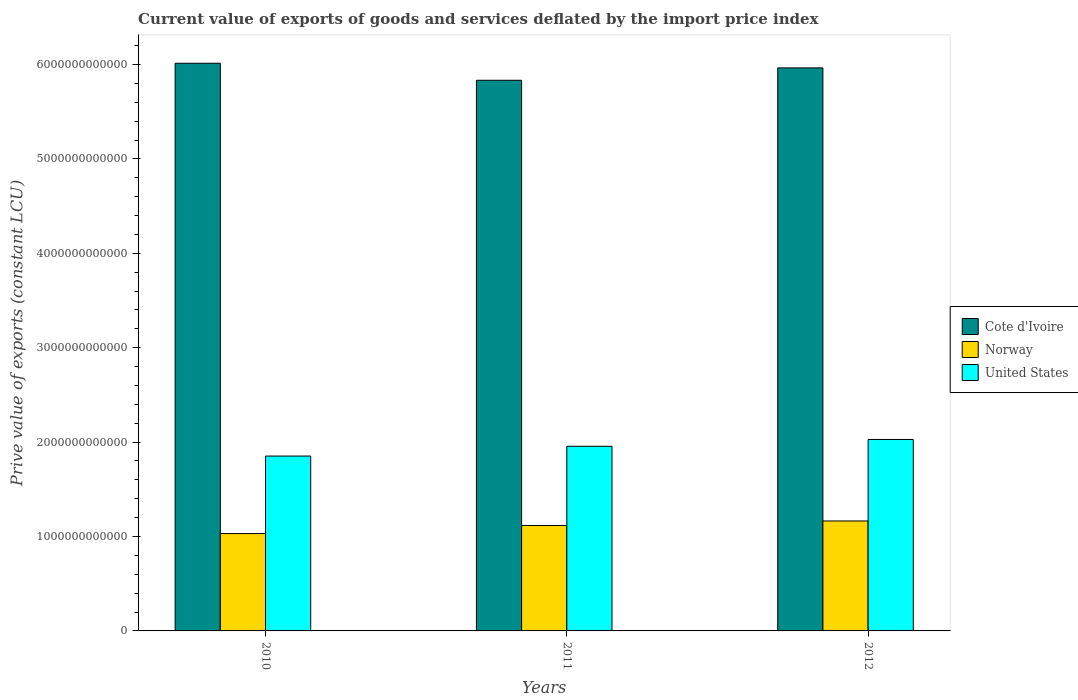Are the number of bars on each tick of the X-axis equal?
Provide a succinct answer. Yes. How many bars are there on the 2nd tick from the left?
Your response must be concise. 3. What is the label of the 1st group of bars from the left?
Your answer should be very brief. 2010. In how many cases, is the number of bars for a given year not equal to the number of legend labels?
Keep it short and to the point. 0. What is the prive value of exports in Cote d'Ivoire in 2010?
Offer a terse response. 6.01e+12. Across all years, what is the maximum prive value of exports in Norway?
Your answer should be compact. 1.16e+12. Across all years, what is the minimum prive value of exports in Norway?
Keep it short and to the point. 1.03e+12. In which year was the prive value of exports in United States maximum?
Provide a short and direct response. 2012. What is the total prive value of exports in Cote d'Ivoire in the graph?
Offer a very short reply. 1.78e+13. What is the difference between the prive value of exports in Cote d'Ivoire in 2010 and that in 2011?
Give a very brief answer. 1.80e+11. What is the difference between the prive value of exports in Norway in 2010 and the prive value of exports in United States in 2012?
Make the answer very short. -9.97e+11. What is the average prive value of exports in Cote d'Ivoire per year?
Your answer should be compact. 5.94e+12. In the year 2010, what is the difference between the prive value of exports in Norway and prive value of exports in United States?
Your answer should be compact. -8.21e+11. What is the ratio of the prive value of exports in Norway in 2011 to that in 2012?
Ensure brevity in your answer.  0.96. Is the prive value of exports in Cote d'Ivoire in 2010 less than that in 2012?
Keep it short and to the point. No. Is the difference between the prive value of exports in Norway in 2010 and 2012 greater than the difference between the prive value of exports in United States in 2010 and 2012?
Your answer should be compact. Yes. What is the difference between the highest and the second highest prive value of exports in Norway?
Ensure brevity in your answer.  4.80e+1. What is the difference between the highest and the lowest prive value of exports in United States?
Offer a terse response. 1.76e+11. In how many years, is the prive value of exports in United States greater than the average prive value of exports in United States taken over all years?
Provide a short and direct response. 2. Is the sum of the prive value of exports in Norway in 2010 and 2011 greater than the maximum prive value of exports in Cote d'Ivoire across all years?
Your answer should be very brief. No. What does the 3rd bar from the left in 2011 represents?
Provide a succinct answer. United States. What does the 3rd bar from the right in 2012 represents?
Your response must be concise. Cote d'Ivoire. How many bars are there?
Your answer should be very brief. 9. Are all the bars in the graph horizontal?
Provide a succinct answer. No. What is the difference between two consecutive major ticks on the Y-axis?
Ensure brevity in your answer.  1.00e+12. Are the values on the major ticks of Y-axis written in scientific E-notation?
Keep it short and to the point. No. Does the graph contain grids?
Keep it short and to the point. No. Where does the legend appear in the graph?
Offer a very short reply. Center right. How are the legend labels stacked?
Your answer should be compact. Vertical. What is the title of the graph?
Keep it short and to the point. Current value of exports of goods and services deflated by the import price index. Does "Maldives" appear as one of the legend labels in the graph?
Offer a very short reply. No. What is the label or title of the Y-axis?
Offer a terse response. Prive value of exports (constant LCU). What is the Prive value of exports (constant LCU) in Cote d'Ivoire in 2010?
Offer a terse response. 6.01e+12. What is the Prive value of exports (constant LCU) of Norway in 2010?
Keep it short and to the point. 1.03e+12. What is the Prive value of exports (constant LCU) in United States in 2010?
Offer a terse response. 1.85e+12. What is the Prive value of exports (constant LCU) of Cote d'Ivoire in 2011?
Provide a short and direct response. 5.83e+12. What is the Prive value of exports (constant LCU) of Norway in 2011?
Give a very brief answer. 1.12e+12. What is the Prive value of exports (constant LCU) of United States in 2011?
Give a very brief answer. 1.96e+12. What is the Prive value of exports (constant LCU) in Cote d'Ivoire in 2012?
Make the answer very short. 5.96e+12. What is the Prive value of exports (constant LCU) of Norway in 2012?
Make the answer very short. 1.16e+12. What is the Prive value of exports (constant LCU) of United States in 2012?
Keep it short and to the point. 2.03e+12. Across all years, what is the maximum Prive value of exports (constant LCU) of Cote d'Ivoire?
Make the answer very short. 6.01e+12. Across all years, what is the maximum Prive value of exports (constant LCU) of Norway?
Make the answer very short. 1.16e+12. Across all years, what is the maximum Prive value of exports (constant LCU) of United States?
Give a very brief answer. 2.03e+12. Across all years, what is the minimum Prive value of exports (constant LCU) of Cote d'Ivoire?
Your answer should be very brief. 5.83e+12. Across all years, what is the minimum Prive value of exports (constant LCU) of Norway?
Offer a very short reply. 1.03e+12. Across all years, what is the minimum Prive value of exports (constant LCU) in United States?
Provide a succinct answer. 1.85e+12. What is the total Prive value of exports (constant LCU) of Cote d'Ivoire in the graph?
Your response must be concise. 1.78e+13. What is the total Prive value of exports (constant LCU) in Norway in the graph?
Provide a succinct answer. 3.31e+12. What is the total Prive value of exports (constant LCU) in United States in the graph?
Your answer should be compact. 5.84e+12. What is the difference between the Prive value of exports (constant LCU) in Cote d'Ivoire in 2010 and that in 2011?
Provide a succinct answer. 1.80e+11. What is the difference between the Prive value of exports (constant LCU) of Norway in 2010 and that in 2011?
Ensure brevity in your answer.  -8.54e+1. What is the difference between the Prive value of exports (constant LCU) of United States in 2010 and that in 2011?
Give a very brief answer. -1.04e+11. What is the difference between the Prive value of exports (constant LCU) of Cote d'Ivoire in 2010 and that in 2012?
Give a very brief answer. 4.91e+1. What is the difference between the Prive value of exports (constant LCU) in Norway in 2010 and that in 2012?
Your response must be concise. -1.33e+11. What is the difference between the Prive value of exports (constant LCU) in United States in 2010 and that in 2012?
Your answer should be very brief. -1.76e+11. What is the difference between the Prive value of exports (constant LCU) in Cote d'Ivoire in 2011 and that in 2012?
Ensure brevity in your answer.  -1.31e+11. What is the difference between the Prive value of exports (constant LCU) of Norway in 2011 and that in 2012?
Keep it short and to the point. -4.80e+1. What is the difference between the Prive value of exports (constant LCU) in United States in 2011 and that in 2012?
Your answer should be very brief. -7.23e+1. What is the difference between the Prive value of exports (constant LCU) of Cote d'Ivoire in 2010 and the Prive value of exports (constant LCU) of Norway in 2011?
Offer a very short reply. 4.90e+12. What is the difference between the Prive value of exports (constant LCU) of Cote d'Ivoire in 2010 and the Prive value of exports (constant LCU) of United States in 2011?
Offer a very short reply. 4.06e+12. What is the difference between the Prive value of exports (constant LCU) in Norway in 2010 and the Prive value of exports (constant LCU) in United States in 2011?
Offer a terse response. -9.24e+11. What is the difference between the Prive value of exports (constant LCU) of Cote d'Ivoire in 2010 and the Prive value of exports (constant LCU) of Norway in 2012?
Provide a short and direct response. 4.85e+12. What is the difference between the Prive value of exports (constant LCU) of Cote d'Ivoire in 2010 and the Prive value of exports (constant LCU) of United States in 2012?
Provide a short and direct response. 3.99e+12. What is the difference between the Prive value of exports (constant LCU) in Norway in 2010 and the Prive value of exports (constant LCU) in United States in 2012?
Provide a short and direct response. -9.97e+11. What is the difference between the Prive value of exports (constant LCU) of Cote d'Ivoire in 2011 and the Prive value of exports (constant LCU) of Norway in 2012?
Keep it short and to the point. 4.67e+12. What is the difference between the Prive value of exports (constant LCU) of Cote d'Ivoire in 2011 and the Prive value of exports (constant LCU) of United States in 2012?
Give a very brief answer. 3.80e+12. What is the difference between the Prive value of exports (constant LCU) in Norway in 2011 and the Prive value of exports (constant LCU) in United States in 2012?
Ensure brevity in your answer.  -9.11e+11. What is the average Prive value of exports (constant LCU) of Cote d'Ivoire per year?
Your response must be concise. 5.94e+12. What is the average Prive value of exports (constant LCU) in Norway per year?
Your response must be concise. 1.10e+12. What is the average Prive value of exports (constant LCU) in United States per year?
Give a very brief answer. 1.95e+12. In the year 2010, what is the difference between the Prive value of exports (constant LCU) of Cote d'Ivoire and Prive value of exports (constant LCU) of Norway?
Ensure brevity in your answer.  4.98e+12. In the year 2010, what is the difference between the Prive value of exports (constant LCU) in Cote d'Ivoire and Prive value of exports (constant LCU) in United States?
Offer a terse response. 4.16e+12. In the year 2010, what is the difference between the Prive value of exports (constant LCU) of Norway and Prive value of exports (constant LCU) of United States?
Offer a terse response. -8.21e+11. In the year 2011, what is the difference between the Prive value of exports (constant LCU) of Cote d'Ivoire and Prive value of exports (constant LCU) of Norway?
Your answer should be very brief. 4.72e+12. In the year 2011, what is the difference between the Prive value of exports (constant LCU) of Cote d'Ivoire and Prive value of exports (constant LCU) of United States?
Your answer should be compact. 3.88e+12. In the year 2011, what is the difference between the Prive value of exports (constant LCU) in Norway and Prive value of exports (constant LCU) in United States?
Your response must be concise. -8.39e+11. In the year 2012, what is the difference between the Prive value of exports (constant LCU) of Cote d'Ivoire and Prive value of exports (constant LCU) of Norway?
Make the answer very short. 4.80e+12. In the year 2012, what is the difference between the Prive value of exports (constant LCU) in Cote d'Ivoire and Prive value of exports (constant LCU) in United States?
Provide a short and direct response. 3.94e+12. In the year 2012, what is the difference between the Prive value of exports (constant LCU) of Norway and Prive value of exports (constant LCU) of United States?
Your response must be concise. -8.63e+11. What is the ratio of the Prive value of exports (constant LCU) in Cote d'Ivoire in 2010 to that in 2011?
Offer a very short reply. 1.03. What is the ratio of the Prive value of exports (constant LCU) in Norway in 2010 to that in 2011?
Offer a very short reply. 0.92. What is the ratio of the Prive value of exports (constant LCU) in United States in 2010 to that in 2011?
Provide a short and direct response. 0.95. What is the ratio of the Prive value of exports (constant LCU) in Cote d'Ivoire in 2010 to that in 2012?
Your answer should be compact. 1.01. What is the ratio of the Prive value of exports (constant LCU) in Norway in 2010 to that in 2012?
Make the answer very short. 0.89. What is the ratio of the Prive value of exports (constant LCU) in United States in 2010 to that in 2012?
Offer a very short reply. 0.91. What is the ratio of the Prive value of exports (constant LCU) in Norway in 2011 to that in 2012?
Offer a terse response. 0.96. What is the ratio of the Prive value of exports (constant LCU) of United States in 2011 to that in 2012?
Offer a terse response. 0.96. What is the difference between the highest and the second highest Prive value of exports (constant LCU) of Cote d'Ivoire?
Keep it short and to the point. 4.91e+1. What is the difference between the highest and the second highest Prive value of exports (constant LCU) in Norway?
Your answer should be compact. 4.80e+1. What is the difference between the highest and the second highest Prive value of exports (constant LCU) of United States?
Give a very brief answer. 7.23e+1. What is the difference between the highest and the lowest Prive value of exports (constant LCU) of Cote d'Ivoire?
Ensure brevity in your answer.  1.80e+11. What is the difference between the highest and the lowest Prive value of exports (constant LCU) in Norway?
Your response must be concise. 1.33e+11. What is the difference between the highest and the lowest Prive value of exports (constant LCU) of United States?
Make the answer very short. 1.76e+11. 